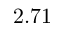<formula> <loc_0><loc_0><loc_500><loc_500>2 . 7 1</formula> 